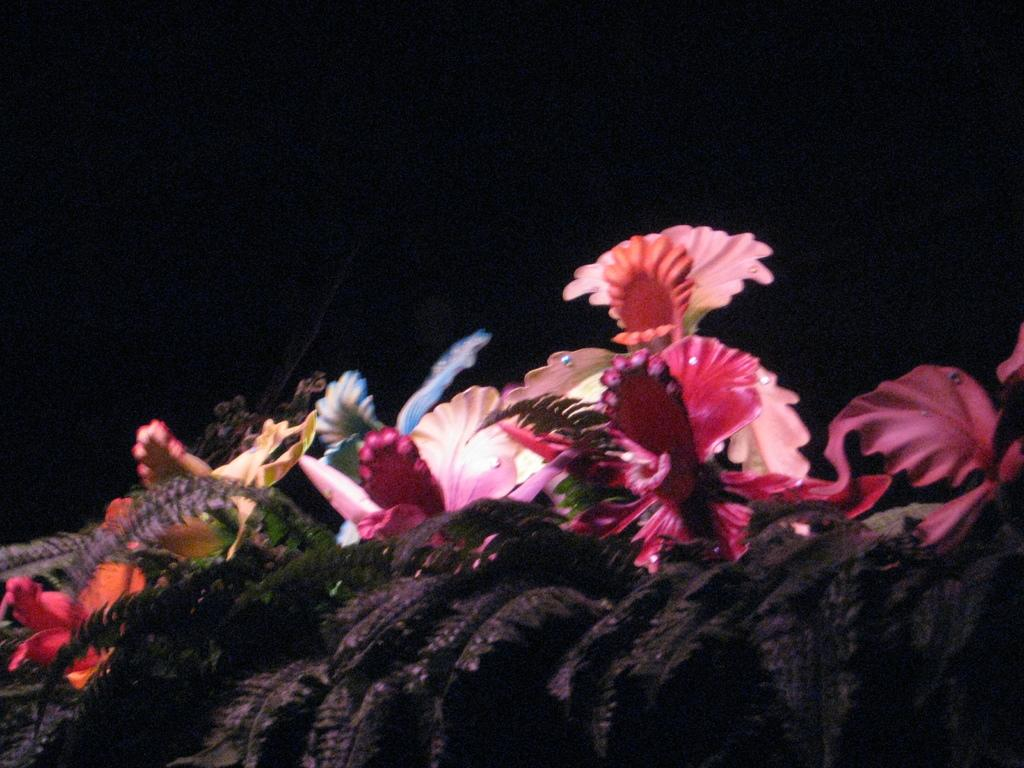What is located in the front of the image? There are flowers in the front of the image. How would you describe the background of the image? The background of the image is dark. How many cars are parked in the garden in the image? There is no garden or car present in the image; it only features flowers in the front and a dark background. 